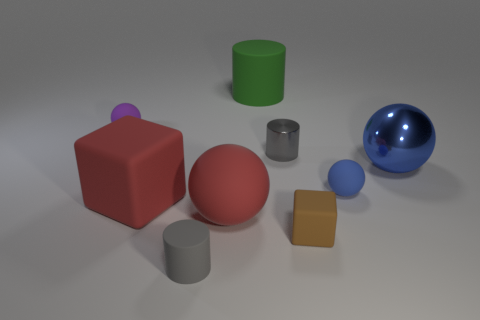What number of matte cylinders are behind the brown rubber cube?
Offer a terse response. 1. There is a small thing that is both behind the brown cube and on the left side of the large green matte thing; what shape is it?
Ensure brevity in your answer.  Sphere. There is a big object that is the same color as the large matte sphere; what is it made of?
Make the answer very short. Rubber. What number of blocks are either large yellow rubber objects or brown objects?
Your answer should be very brief. 1. What size is the matte cylinder that is the same color as the small metal thing?
Offer a terse response. Small. Is the number of blue matte spheres that are behind the blue rubber ball less than the number of small balls?
Your response must be concise. Yes. There is a tiny rubber object that is both on the left side of the small rubber block and on the right side of the purple matte object; what color is it?
Offer a very short reply. Gray. How many other objects are there of the same shape as the big blue thing?
Provide a short and direct response. 3. Are there fewer metal objects right of the brown object than brown matte cubes on the right side of the tiny blue sphere?
Keep it short and to the point. No. Do the green cylinder and the tiny blue sphere right of the purple sphere have the same material?
Your answer should be very brief. Yes. 